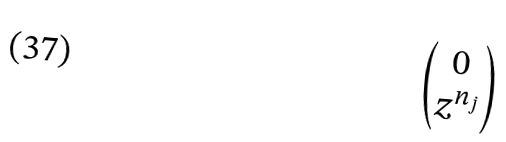<formula> <loc_0><loc_0><loc_500><loc_500>\begin{pmatrix} 0 \\ z ^ { n _ { j } } \end{pmatrix}</formula> 